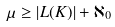Convert formula to latex. <formula><loc_0><loc_0><loc_500><loc_500>\mu \geq | L ( K ) | + \aleph _ { 0 }</formula> 